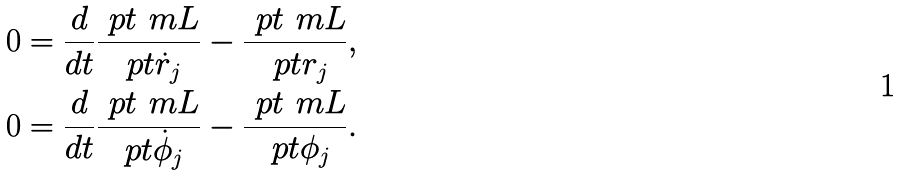<formula> <loc_0><loc_0><loc_500><loc_500>0 & = \frac { d } { d t } \frac { \ p t \ m L } { \ p t \dot { r } _ { j } } - \frac { \ p t \ m L } { \ p t r _ { j } } , \\ 0 & = \frac { d } { d t } \frac { \ p t \ m L } { \ p t \dot { \phi } _ { j } } - \frac { \ p t \ m L } { \ p t \phi _ { j } } .</formula> 